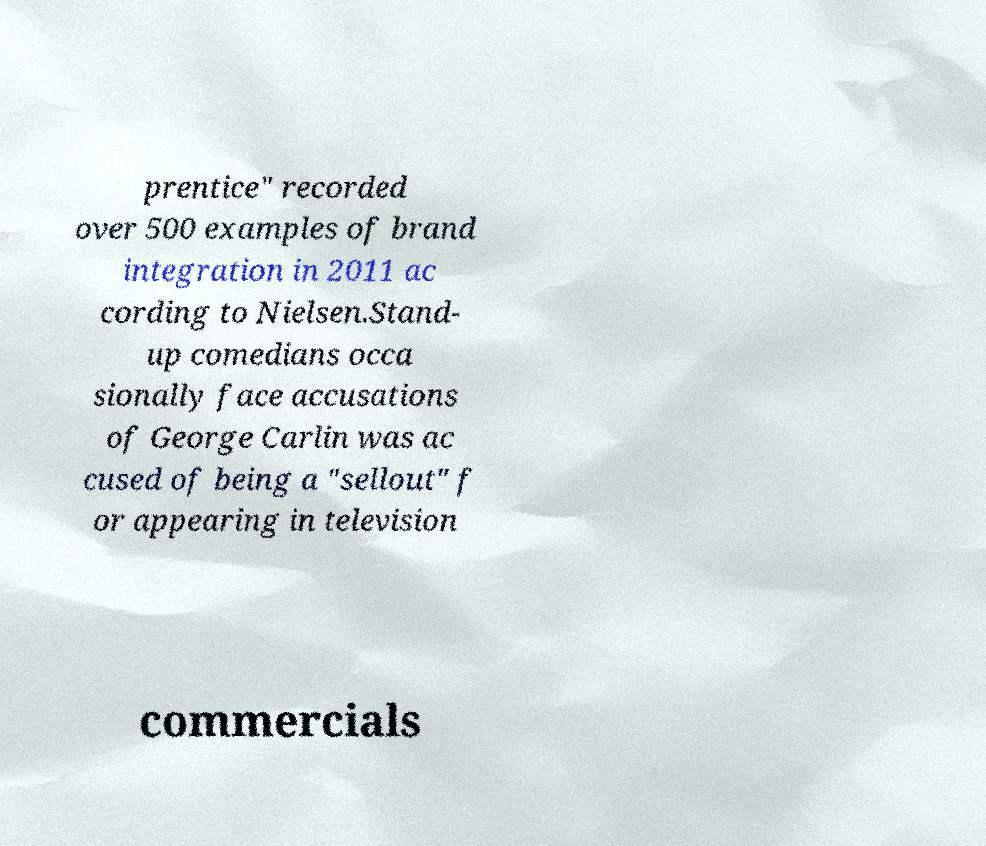Could you assist in decoding the text presented in this image and type it out clearly? prentice" recorded over 500 examples of brand integration in 2011 ac cording to Nielsen.Stand- up comedians occa sionally face accusations of George Carlin was ac cused of being a "sellout" f or appearing in television commercials 